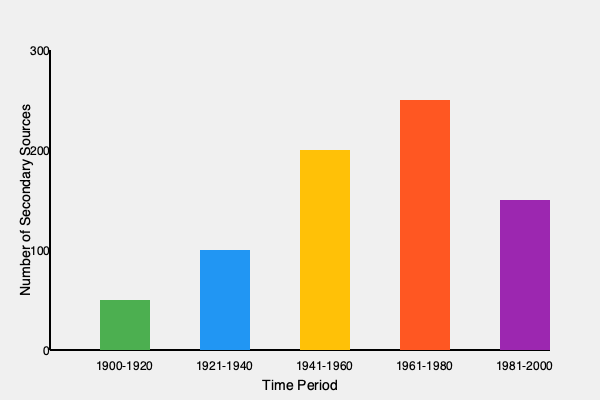Analyze the distribution of secondary sources across different time periods as shown in the timeline visualization. Which period saw the most significant increase in the number of secondary sources compared to the previous period, and what might this suggest about historical research trends? To answer this question, we need to follow these steps:

1. Identify the number of secondary sources for each time period:
   1900-1920: 50 sources
   1921-1940: 100 sources
   1941-1960: 200 sources
   1961-1980: 250 sources
   1981-2000: 150 sources

2. Calculate the increase between each consecutive period:
   1921-1940 vs. 1900-1920: 100 - 50 = 50 increase
   1941-1960 vs. 1921-1940: 200 - 100 = 100 increase
   1961-1980 vs. 1941-1960: 250 - 200 = 50 increase
   1981-2000 vs. 1961-1980: 150 - 250 = -100 decrease

3. Identify the largest increase:
   The largest increase is 100 sources, occurring between 1921-1940 and 1941-1960.

4. Interpret the significance:
   This significant increase suggests a surge in historical research and writing about the events of 1941-1960, which encompasses World War II and the early Cold War period. This trend might indicate:
   a) Increased interest in analyzing recent historical events
   b) Greater availability of primary sources from this period
   c) The emergence of new historical methodologies or perspectives
   d) A shift in academic focus towards contemporary history

5. Consider broader implications:
   This trend reflects the evolving nature of historical research, where more recent events often garner increased attention as they become historically significant and as more sources become available for analysis.
Answer: 1941-1960; surge in research on WWII and early Cold War. 